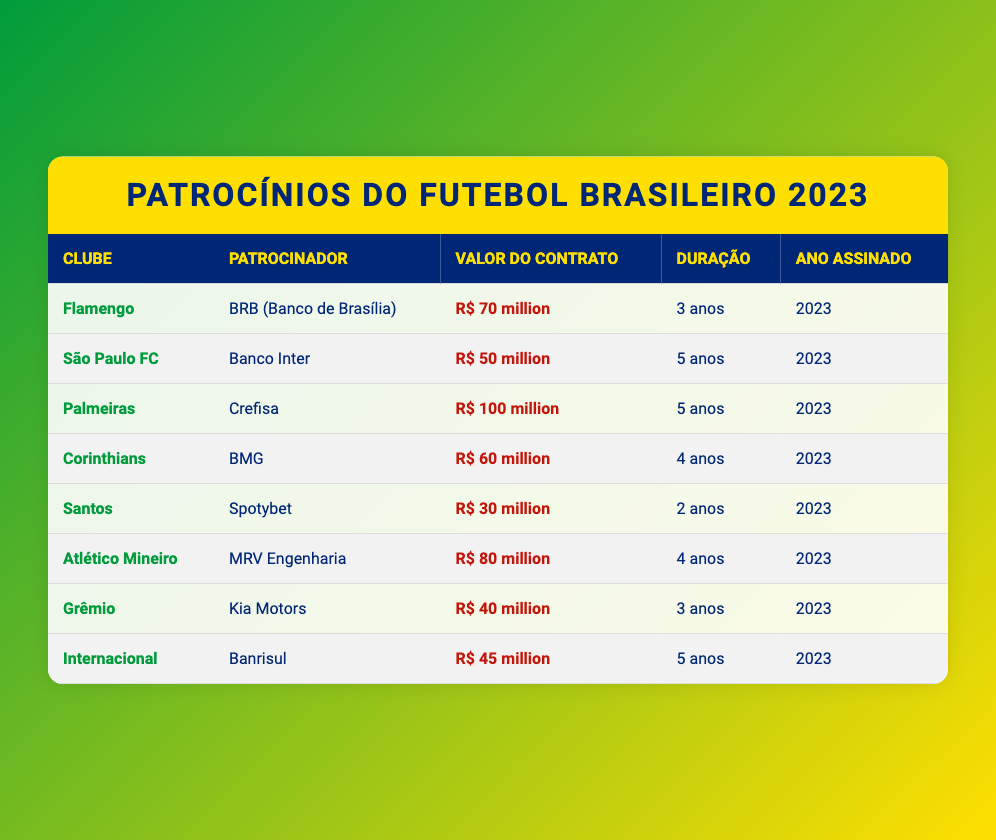What is the total value of all sponsorship deals for Brazilian soccer clubs in 2023? To find the total value, sum all individual deal values: R$ 70 million (Flamengo) + R$ 50 million (São Paulo FC) + R$ 100 million (Palmeiras) + R$ 60 million (Corinthians) + R$ 30 million (Santos) + R$ 80 million (Atlético Mineiro) + R$ 40 million (Grêmio) + R$ 45 million (Internacional) = R$ 475 million.
Answer: R$ 475 million Which club has the longest sponsorship deal duration? The longest duration is 5 years, which applies to São Paulo FC and Palmeiras as both have deals for that duration.
Answer: São Paulo FC and Palmeiras How much is Palmeiras' sponsorship deal worth compared to Santos'? Palmeiras has a sponsorship worth R$ 100 million, and Santos' is worth R$ 30 million. The difference is R$ 100 million - R$ 30 million = R$ 70 million.
Answer: R$ 70 million Is the deal value for Internacional greater than the deal value for Grêmio? Internacional's deal value is R$ 45 million, while Grêmio's is R$ 40 million. Since R$ 45 million is greater than R$ 40 million, the statement is true.
Answer: Yes What percentage of the total sponsorship value does Palmeiras' deal represent? The total sponsorship value is R$ 475 million, and Palmeiras' deal is R$ 100 million. To find the percentage, calculate (100/475) * 100 = 21.05%.
Answer: 21.05% Which sponsorship deal has the highest value and its duration? The highest sponsorship deal value is R$ 100 million, which belongs to Palmeiras, and the duration is 5 years.
Answer: R$ 100 million for 5 years How many clubs have sponsorship deals lasting for 4 years? There are two clubs with a 4-year duration: Corinthians and Atlético Mineiro.
Answer: 2 clubs What is the average deal value for the clubs with 3-year sponsorships? The clubs with 3-year deals are Flamengo (R$ 70 million), Grêmio (R$ 40 million). Average = (70 + 40) / 2 = R$ 55 million.
Answer: R$ 55 million Is the sponsorship deal value of Santos less than the average deal value for all clubs? The average deal value for all clubs was calculated previously as R$ 59.375 million. Santos has a deal for R$ 30 million, which is less than R$ 59.375 million. So, the statement is true.
Answer: Yes Who has the lowest sponsorship deal value, and how much is it? Santos has the lowest sponsorship deal at R$ 30 million.
Answer: Santos - R$ 30 million 